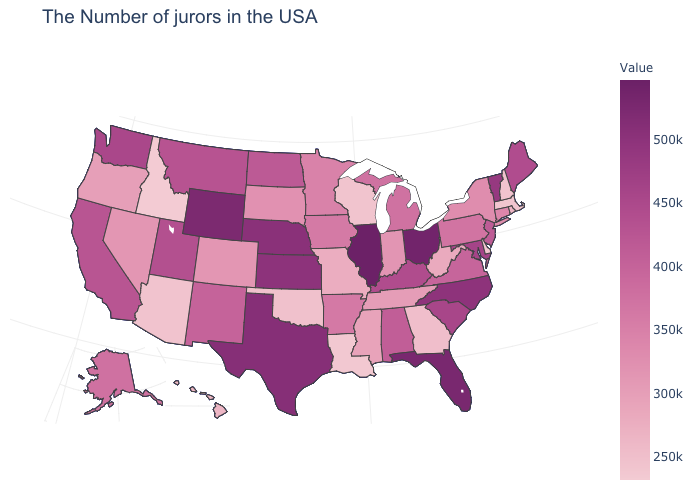Does Idaho have the lowest value in the USA?
Concise answer only. Yes. Does Massachusetts have the lowest value in the Northeast?
Keep it brief. Yes. Does Illinois have the highest value in the MidWest?
Answer briefly. Yes. Is the legend a continuous bar?
Short answer required. Yes. Does Missouri have the lowest value in the USA?
Concise answer only. No. Which states hav the highest value in the South?
Give a very brief answer. Florida. Does Arkansas have the highest value in the South?
Concise answer only. No. 